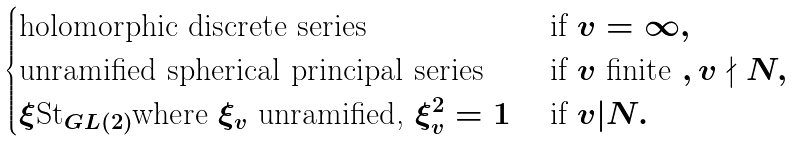Convert formula to latex. <formula><loc_0><loc_0><loc_500><loc_500>\begin{cases} \text {holomorphic discrete series} & \text { if } v = \infty , \\ \text {unramified spherical principal series} & \text { if } v \text { finite } , v \nmid N , \\ \xi \text {St} _ { G L ( 2 ) } \text {where } \xi _ { v } \text { unramified, } \xi _ { v } ^ { 2 } = 1 & \text { if } v | N . \end{cases}</formula> 